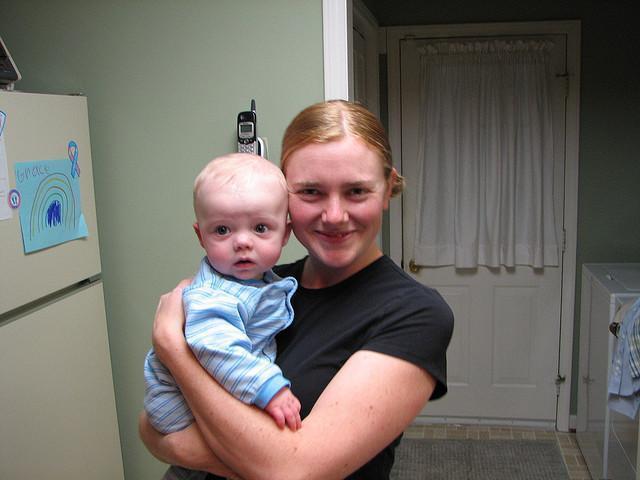Why is she smiling?
Choose the right answer and clarify with the format: 'Answer: answer
Rationale: rationale.'
Options: Is confused, has child, is proud, selling baby. Answer: is proud.
Rationale: Mother and baby are looking at the camera. she is happy and loves the little boy. 